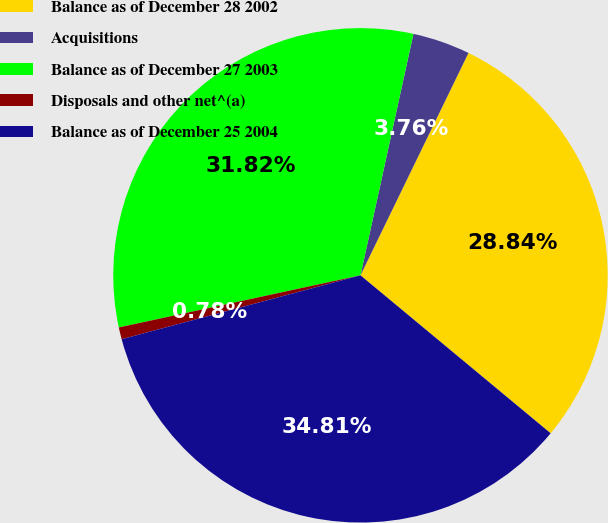<chart> <loc_0><loc_0><loc_500><loc_500><pie_chart><fcel>Balance as of December 28 2002<fcel>Acquisitions<fcel>Balance as of December 27 2003<fcel>Disposals and other net^(a)<fcel>Balance as of December 25 2004<nl><fcel>28.84%<fcel>3.76%<fcel>31.82%<fcel>0.78%<fcel>34.81%<nl></chart> 